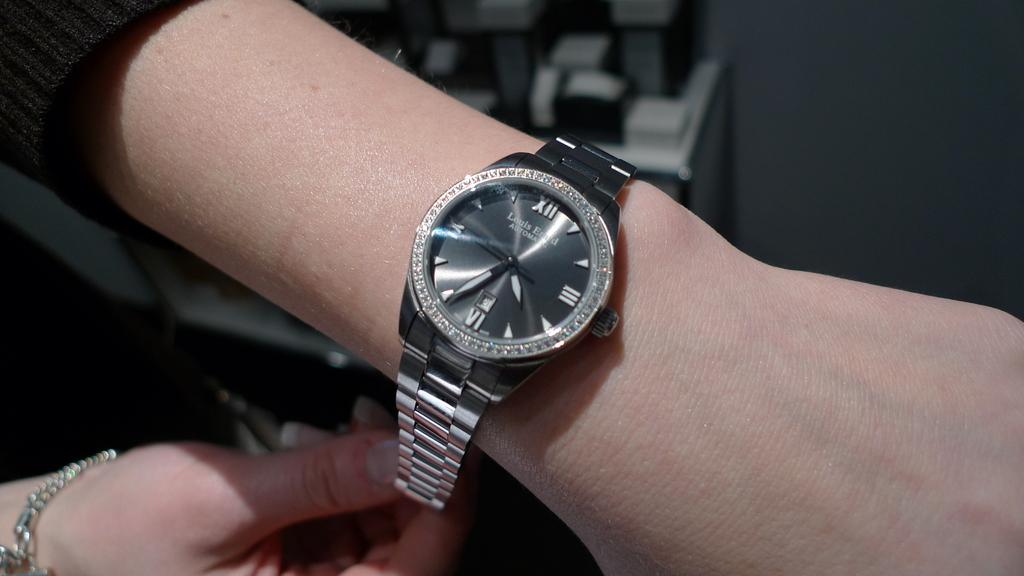Provide a one-sentence caption for the provided image. The watch on the woman's left wrist says that it is nearly 4:35. 